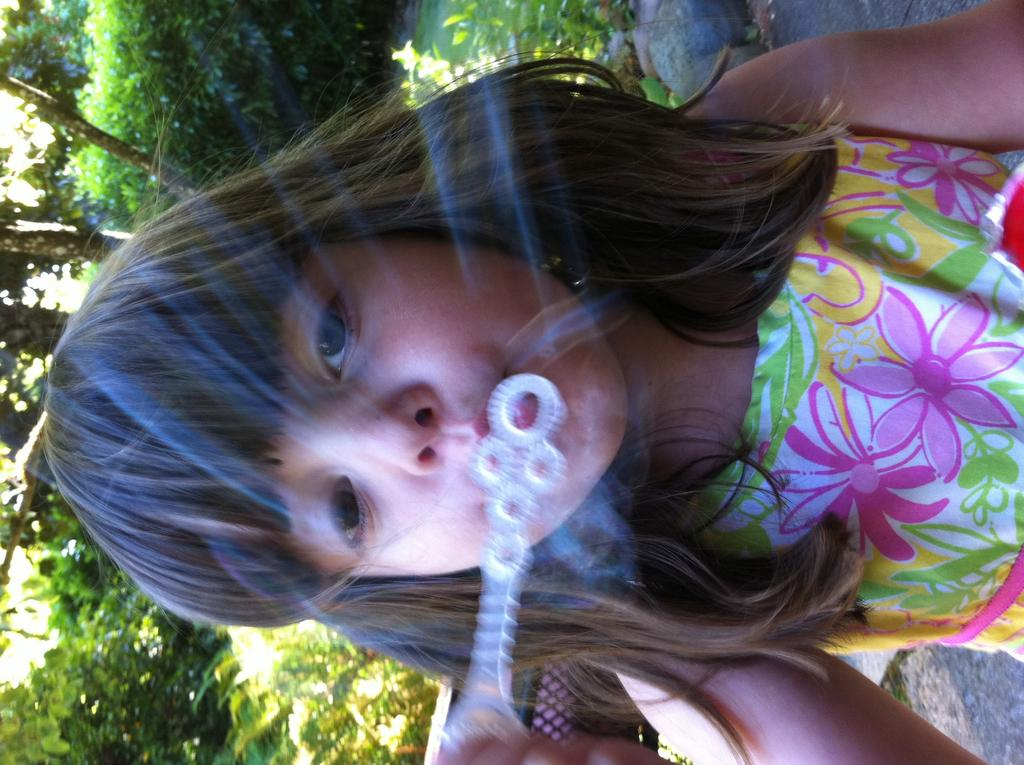Who is the main subject in the picture? There is a girl in the picture. What is the girl doing in the picture? The girl is blowing a bubble. What can be seen in the background of the picture? There are trees behind the girl. How many buns are on the girl's head in the image? There are no buns present on the girl's head in the image. What type of work is the girl doing as a slave in the image? There is no indication of the girl being a slave or performing any work in the image. 